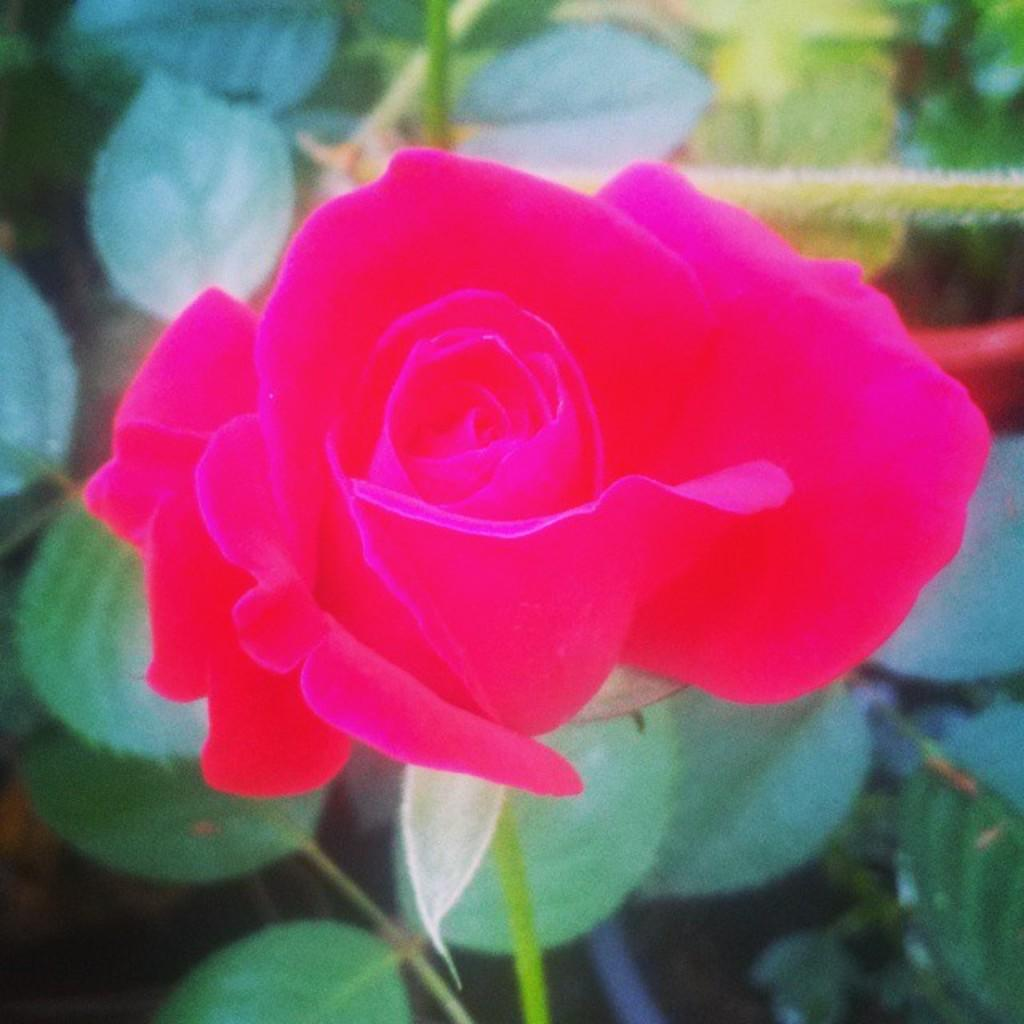What type of flower is in the image? There is a rose flower in the image. What other parts of the rose flower can be seen besides the petals? The rose flower has leaves. What color is the rose flower in the image? The rose flower is pink in color. What type of sweater is the rose flower wearing in the image? There is no sweater present in the image, as the subject is a rose flower. 